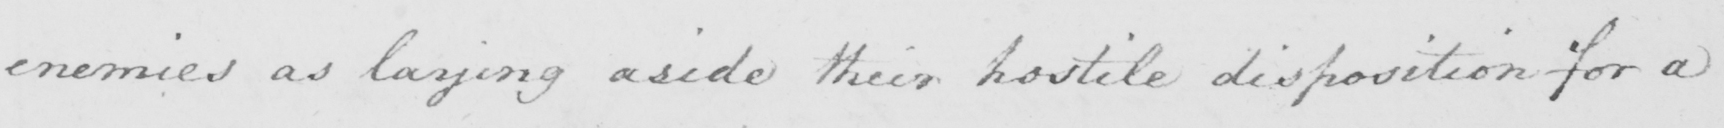Transcribe the text shown in this historical manuscript line. enemies as laying aside their hostile disposition for a 